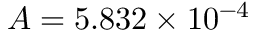Convert formula to latex. <formula><loc_0><loc_0><loc_500><loc_500>A = 5 . 8 3 2 \times 1 0 ^ { - 4 }</formula> 